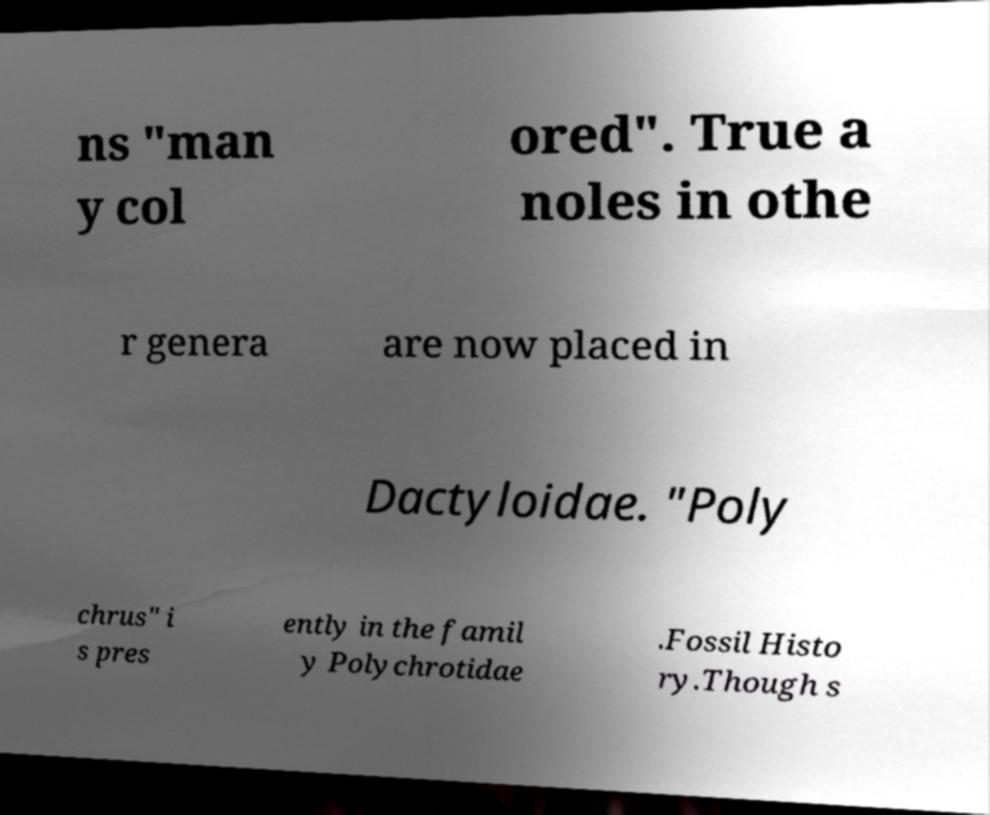I need the written content from this picture converted into text. Can you do that? ns "man y col ored". True a noles in othe r genera are now placed in Dactyloidae. "Poly chrus" i s pres ently in the famil y Polychrotidae .Fossil Histo ry.Though s 